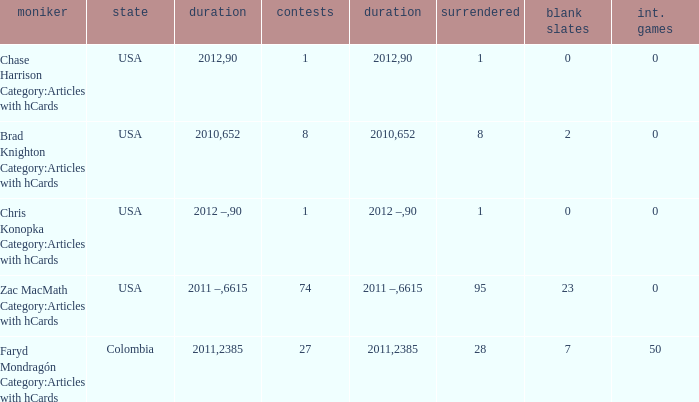When  chris konopka category:articles with hcards is the name what is the year? 2012 –. 